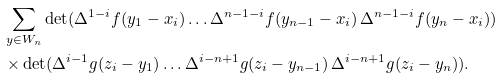Convert formula to latex. <formula><loc_0><loc_0><loc_500><loc_500>& \sum _ { y \in W _ { n } } \det ( \Delta ^ { 1 - i } f ( y _ { 1 } - x _ { i } ) \dots \Delta ^ { n - 1 - i } f ( y _ { n - 1 } - x _ { i } ) \, \Delta ^ { n - 1 - i } f ( y _ { n } - x _ { i } ) ) \\ & \times \det ( \Delta ^ { i - 1 } g ( z _ { i } - y _ { 1 } ) \dots \Delta ^ { i - n + 1 } g ( z _ { i } - y _ { n - 1 } ) \, \Delta ^ { i - n + 1 } g ( z _ { i } - y _ { n } ) ) .</formula> 